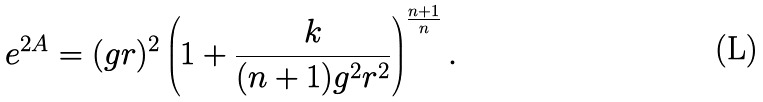<formula> <loc_0><loc_0><loc_500><loc_500>e ^ { 2 A } = ( g r ) ^ { 2 } \left ( 1 + { \frac { k } { ( n + 1 ) g ^ { 2 } r ^ { 2 } } } \right ) ^ { { \frac { n + 1 } { n } } } .</formula> 